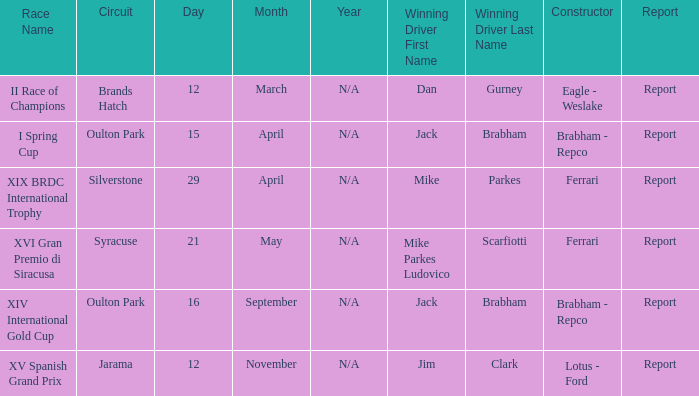What is the name of the race on 16 september? XIV International Gold Cup. 